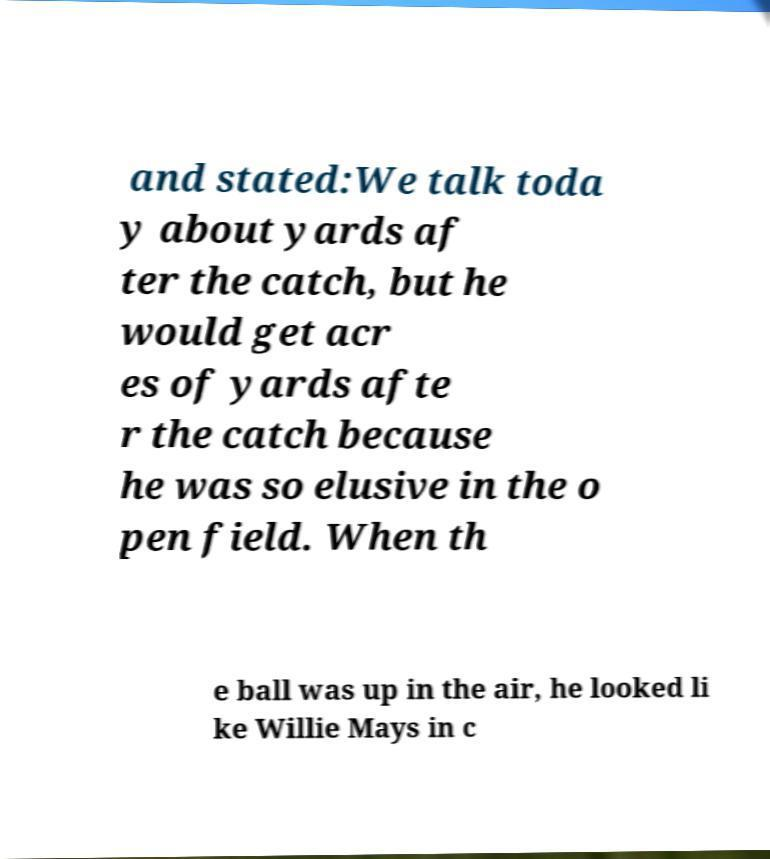Please identify and transcribe the text found in this image. and stated:We talk toda y about yards af ter the catch, but he would get acr es of yards afte r the catch because he was so elusive in the o pen field. When th e ball was up in the air, he looked li ke Willie Mays in c 